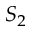Convert formula to latex. <formula><loc_0><loc_0><loc_500><loc_500>S _ { 2 }</formula> 